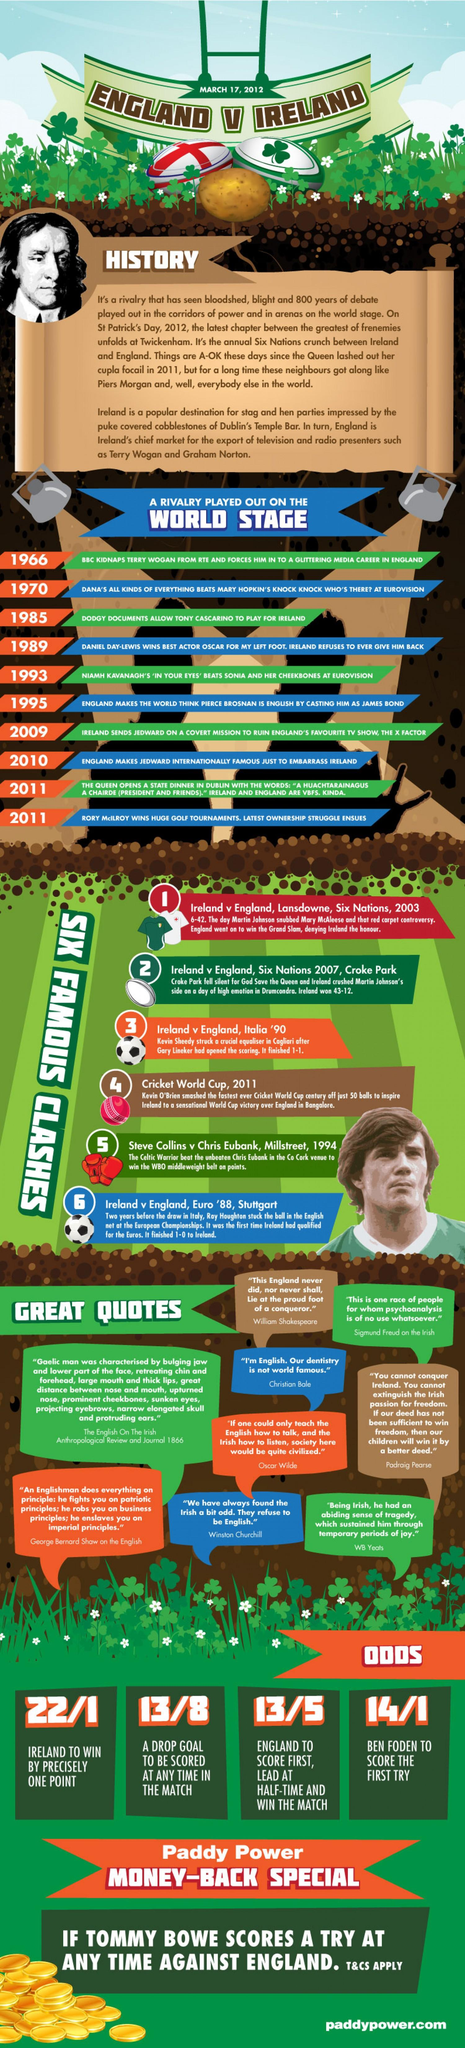Draw attention to some important aspects in this diagram. In a closely contested match, when Ireland was on the verge of victory with only one point difference, all of a sudden, their opponent team's batsmen were able to score 6 wickets, which ultimately led to Ireland's defeat. England won the match with a final score of 13-5, having led at half time. 